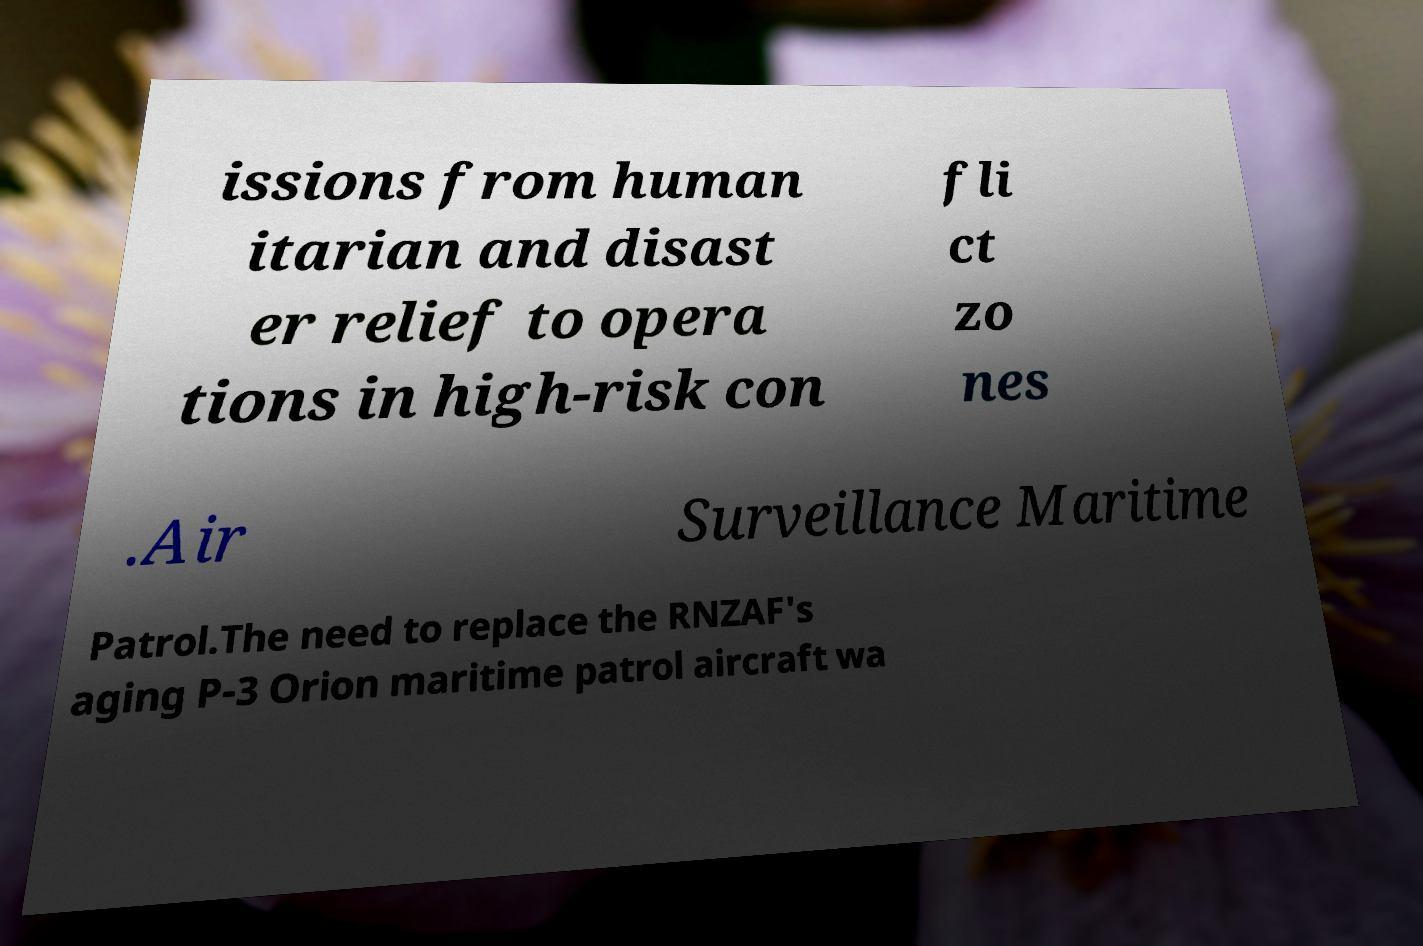Please identify and transcribe the text found in this image. issions from human itarian and disast er relief to opera tions in high-risk con fli ct zo nes .Air Surveillance Maritime Patrol.The need to replace the RNZAF's aging P-3 Orion maritime patrol aircraft wa 